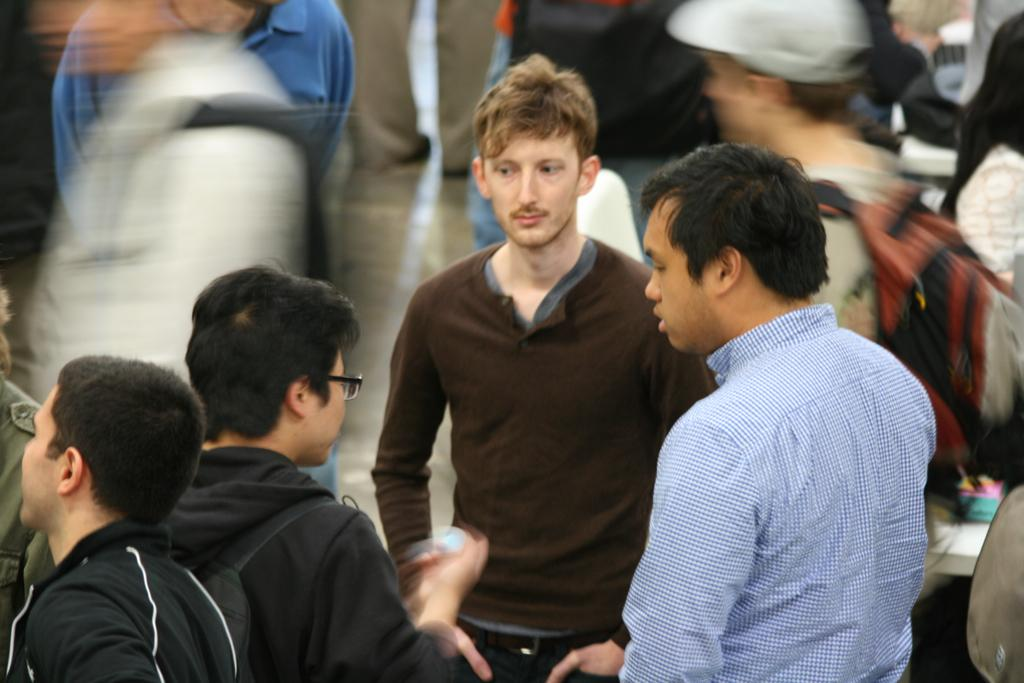Who or what is present in the image? There are people in the image. What objects can be seen on the right side of the image? There is a table and a chair on the right side of the image. Can you describe the background of the image? The background of the image is blurry. What type of invention can be seen in the background of the image? There is no invention present in the image; the background is blurry. How many cows are visible in the image? There are no cows present in the image. 